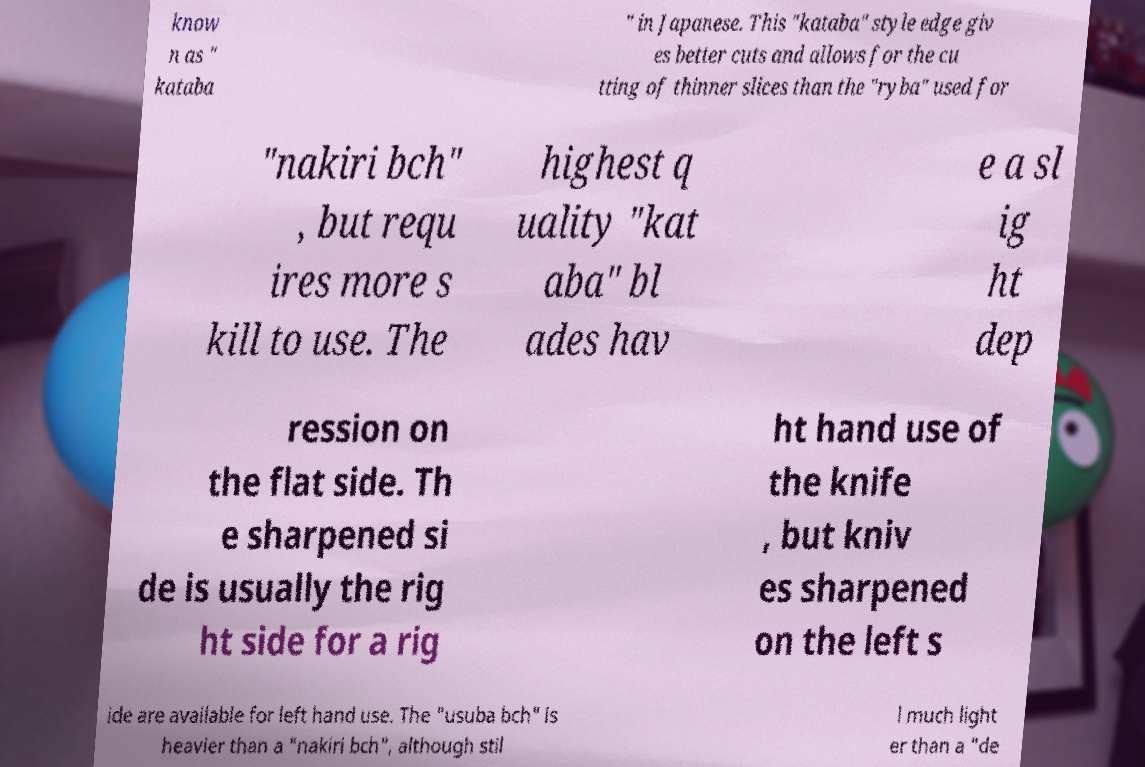Can you accurately transcribe the text from the provided image for me? know n as " kataba " in Japanese. This "kataba" style edge giv es better cuts and allows for the cu tting of thinner slices than the "ryba" used for "nakiri bch" , but requ ires more s kill to use. The highest q uality "kat aba" bl ades hav e a sl ig ht dep ression on the flat side. Th e sharpened si de is usually the rig ht side for a rig ht hand use of the knife , but kniv es sharpened on the left s ide are available for left hand use. The "usuba bch" is heavier than a "nakiri bch", although stil l much light er than a "de 